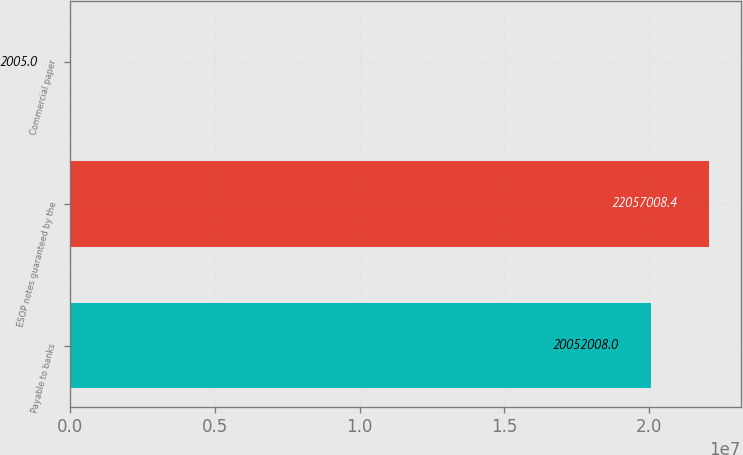<chart> <loc_0><loc_0><loc_500><loc_500><bar_chart><fcel>Payable to banks<fcel>ESOP notes guaranteed by the<fcel>Commercial paper<nl><fcel>2.0052e+07<fcel>2.2057e+07<fcel>2005<nl></chart> 